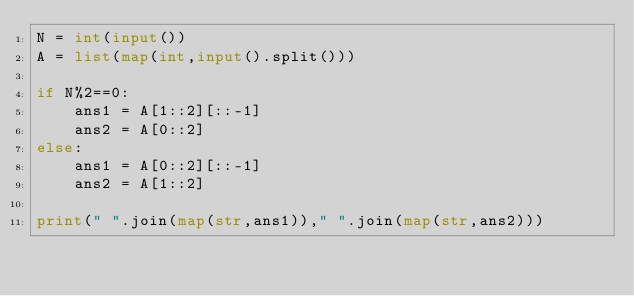Convert code to text. <code><loc_0><loc_0><loc_500><loc_500><_Python_>N = int(input())
A = list(map(int,input().split()))

if N%2==0:
    ans1 = A[1::2][::-1]
    ans2 = A[0::2]
else:
    ans1 = A[0::2][::-1]
    ans2 = A[1::2]

print(" ".join(map(str,ans1))," ".join(map(str,ans2)))</code> 